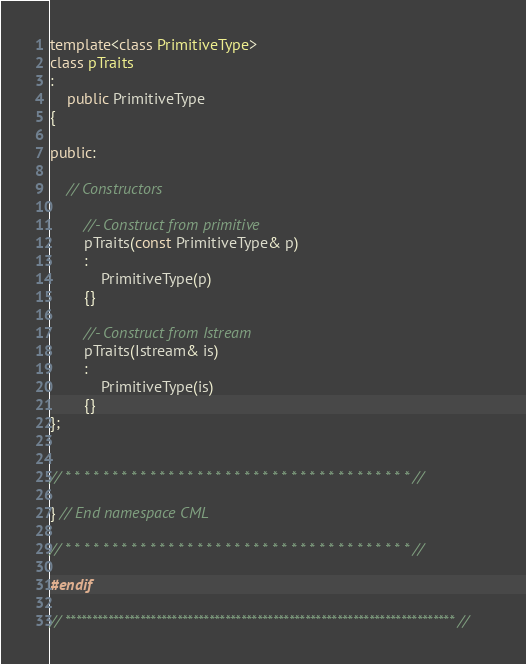<code> <loc_0><loc_0><loc_500><loc_500><_C++_>
template<class PrimitiveType>
class pTraits
:
    public PrimitiveType
{

public:

    // Constructors

        //- Construct from primitive
        pTraits(const PrimitiveType& p)
        :
            PrimitiveType(p)
        {}

        //- Construct from Istream
        pTraits(Istream& is)
        :
            PrimitiveType(is)
        {}
};


// * * * * * * * * * * * * * * * * * * * * * * * * * * * * * * * * * * * * * //

} // End namespace CML

// * * * * * * * * * * * * * * * * * * * * * * * * * * * * * * * * * * * * * //

#endif

// ************************************************************************* //
</code> 